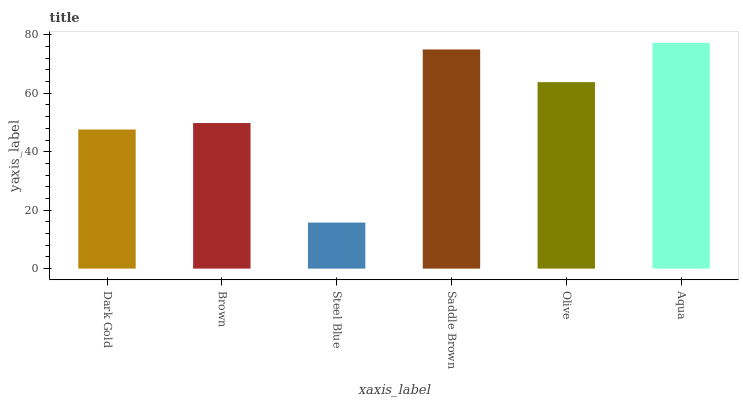Is Steel Blue the minimum?
Answer yes or no. Yes. Is Aqua the maximum?
Answer yes or no. Yes. Is Brown the minimum?
Answer yes or no. No. Is Brown the maximum?
Answer yes or no. No. Is Brown greater than Dark Gold?
Answer yes or no. Yes. Is Dark Gold less than Brown?
Answer yes or no. Yes. Is Dark Gold greater than Brown?
Answer yes or no. No. Is Brown less than Dark Gold?
Answer yes or no. No. Is Olive the high median?
Answer yes or no. Yes. Is Brown the low median?
Answer yes or no. Yes. Is Saddle Brown the high median?
Answer yes or no. No. Is Aqua the low median?
Answer yes or no. No. 